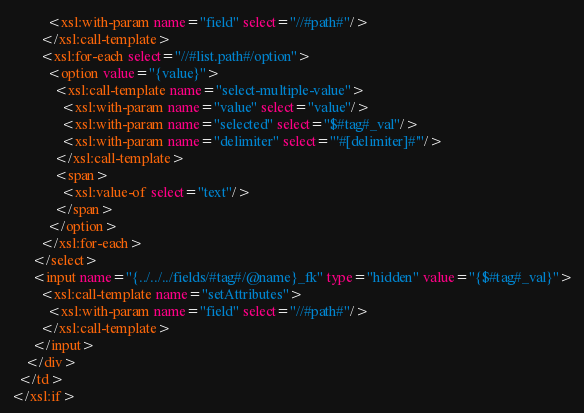Convert code to text. <code><loc_0><loc_0><loc_500><loc_500><_HTML_>          <xsl:with-param name="field" select="//#path#"/>
        </xsl:call-template>
        <xsl:for-each select="//#list.path#/option">
          <option value="{value}">
            <xsl:call-template name="select-multiple-value">
              <xsl:with-param name="value" select="value"/>
              <xsl:with-param name="selected" select="$#tag#_val"/>
              <xsl:with-param name="delimiter" select="'#[delimiter]#'"/>
            </xsl:call-template>
            <span>
              <xsl:value-of select="text"/>
            </span>
          </option>
        </xsl:for-each>
      </select>
      <input name="{../../../fields/#tag#/@name}_fk" type="hidden" value="{$#tag#_val}">
      	<xsl:call-template name="setAttributes">
          <xsl:with-param name="field" select="//#path#"/>
        </xsl:call-template>
      </input>
    </div>
  </td>
</xsl:if>

</code> 